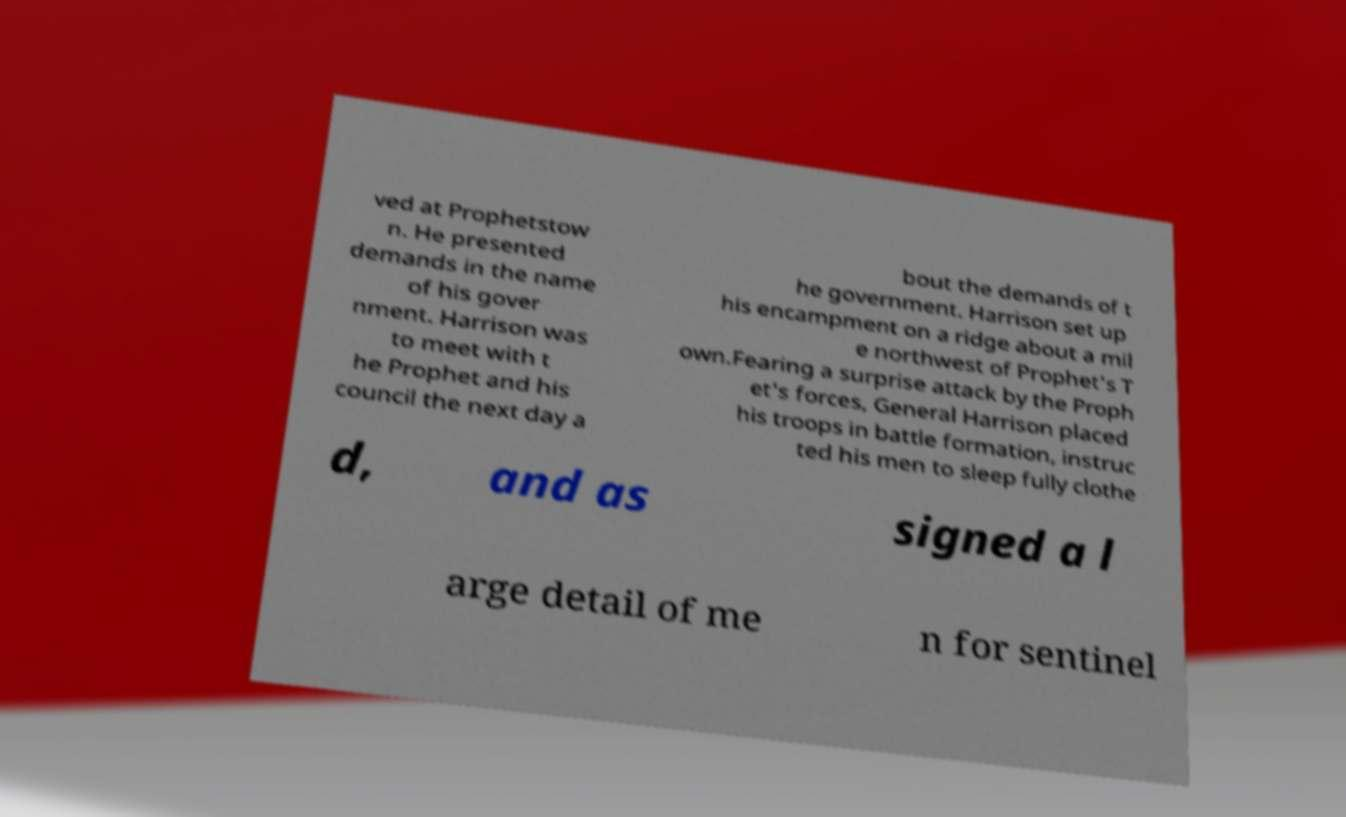Could you extract and type out the text from this image? ved at Prophetstow n. He presented demands in the name of his gover nment. Harrison was to meet with t he Prophet and his council the next day a bout the demands of t he government. Harrison set up his encampment on a ridge about a mil e northwest of Prophet's T own.Fearing a surprise attack by the Proph et's forces, General Harrison placed his troops in battle formation, instruc ted his men to sleep fully clothe d, and as signed a l arge detail of me n for sentinel 